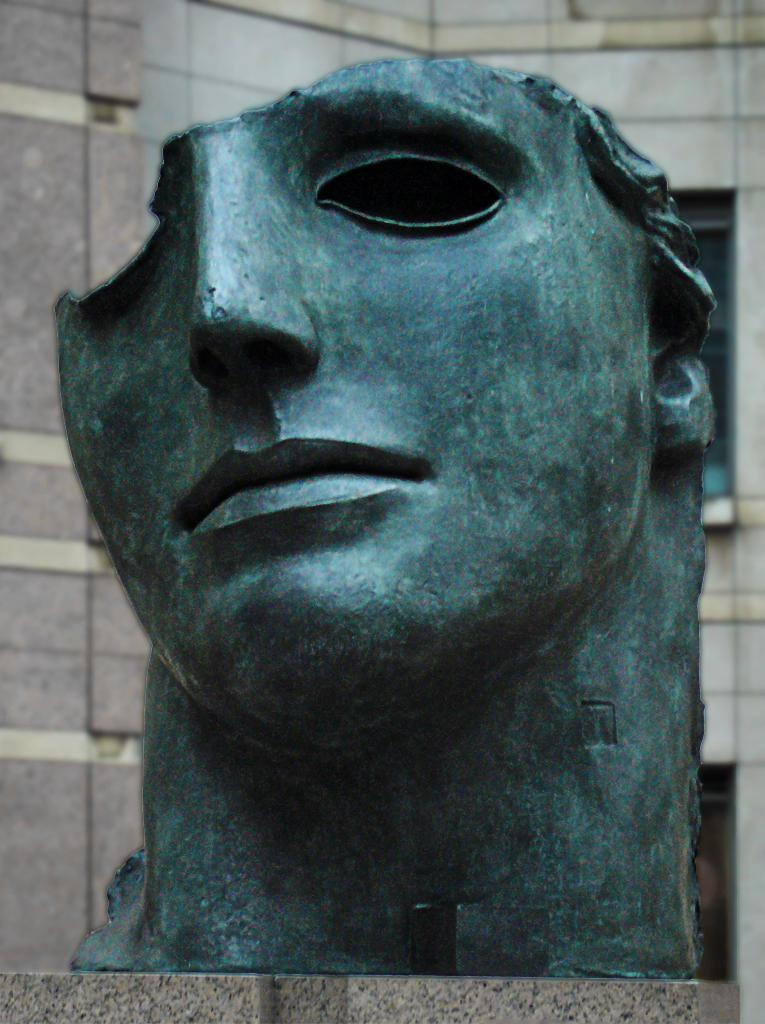What is the main subject of the image? There is a sculpture of a human face in the image. What color is the sculpture? The sculpture is green in color. What can be seen in the background of the image? There is a building in the background of the image. What type of pancake is being served on the crown in the image? There is no pancake or crown present in the image; it features a green sculpture of a human face and a building in the background. 